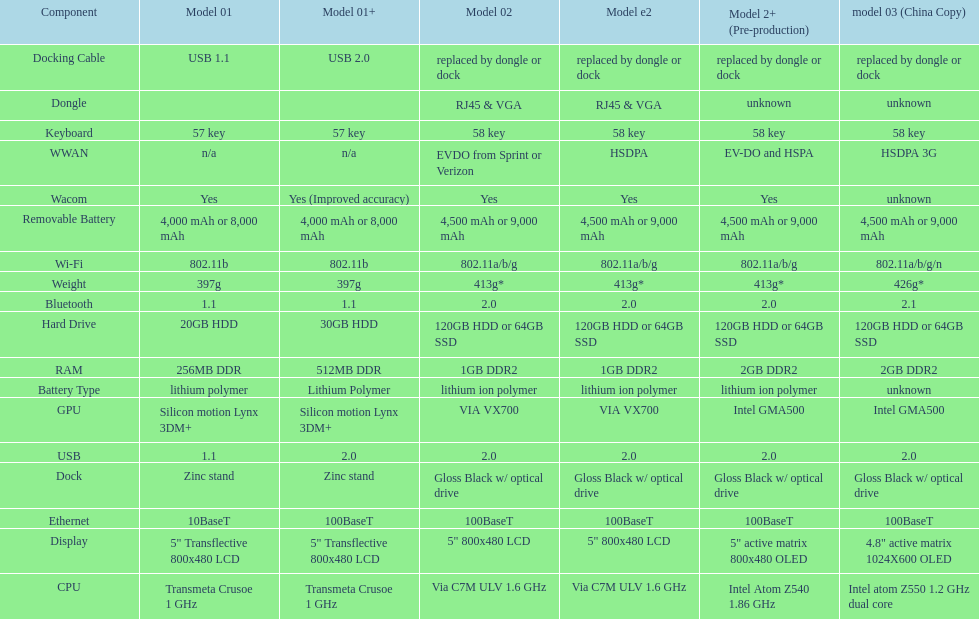What is the component before usb? Display. 